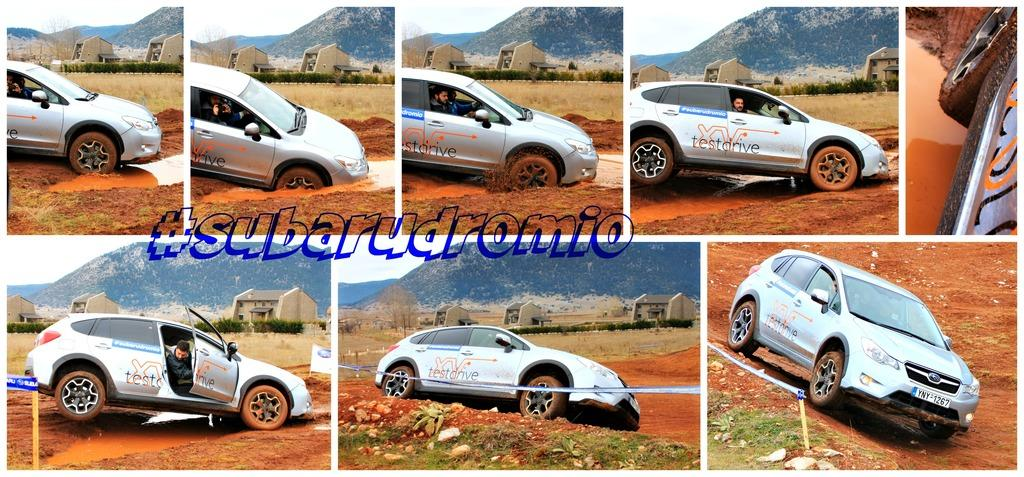What is the main subject of the image? The image contains a collage. What types of vehicles are included in the collage? There are vehicles in the collage. What type of structures can be seen in the collage? There are sheds in the collage. What natural features are present in the collage? There are mountains and trees in the collage. What other objects are included in the collage? There are objects in the collage. Is there any text present in the collage? Yes, there is text present in the collage. What type of destruction can be seen in the image? There is no destruction present in the image; it is a collage containing various elements. 